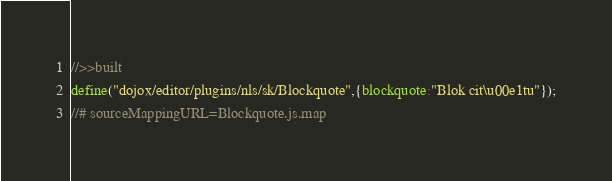Convert code to text. <code><loc_0><loc_0><loc_500><loc_500><_JavaScript_>//>>built
define("dojox/editor/plugins/nls/sk/Blockquote",{blockquote:"Blok cit\u00e1tu"});
//# sourceMappingURL=Blockquote.js.map</code> 